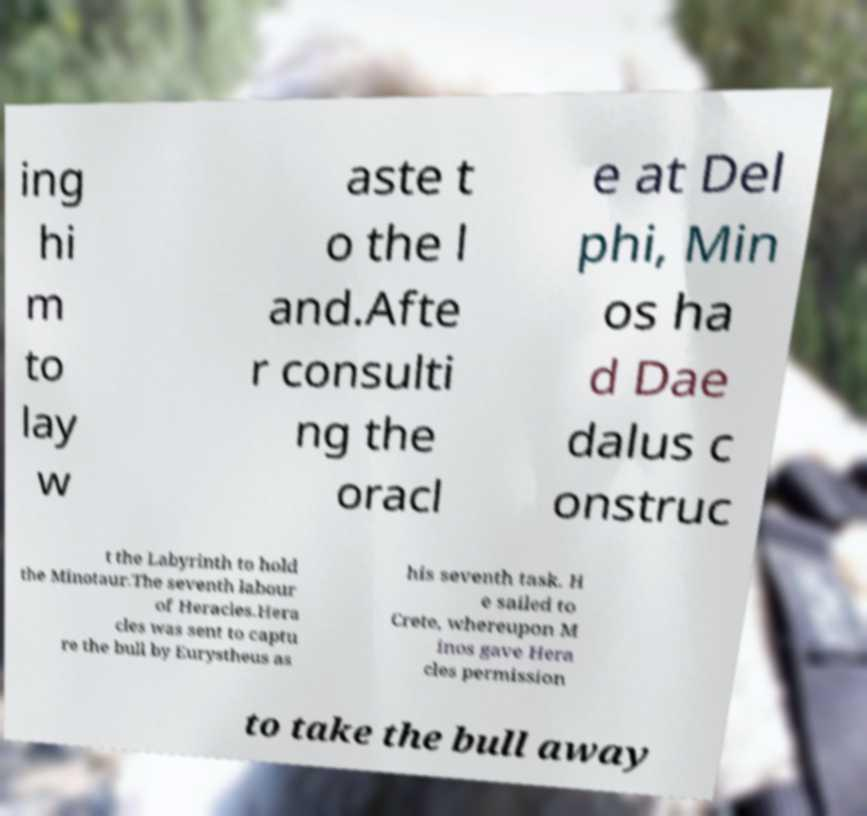I need the written content from this picture converted into text. Can you do that? ing hi m to lay w aste t o the l and.Afte r consulti ng the oracl e at Del phi, Min os ha d Dae dalus c onstruc t the Labyrinth to hold the Minotaur.The seventh labour of Heracles.Hera cles was sent to captu re the bull by Eurystheus as his seventh task. H e sailed to Crete, whereupon M inos gave Hera cles permission to take the bull away 